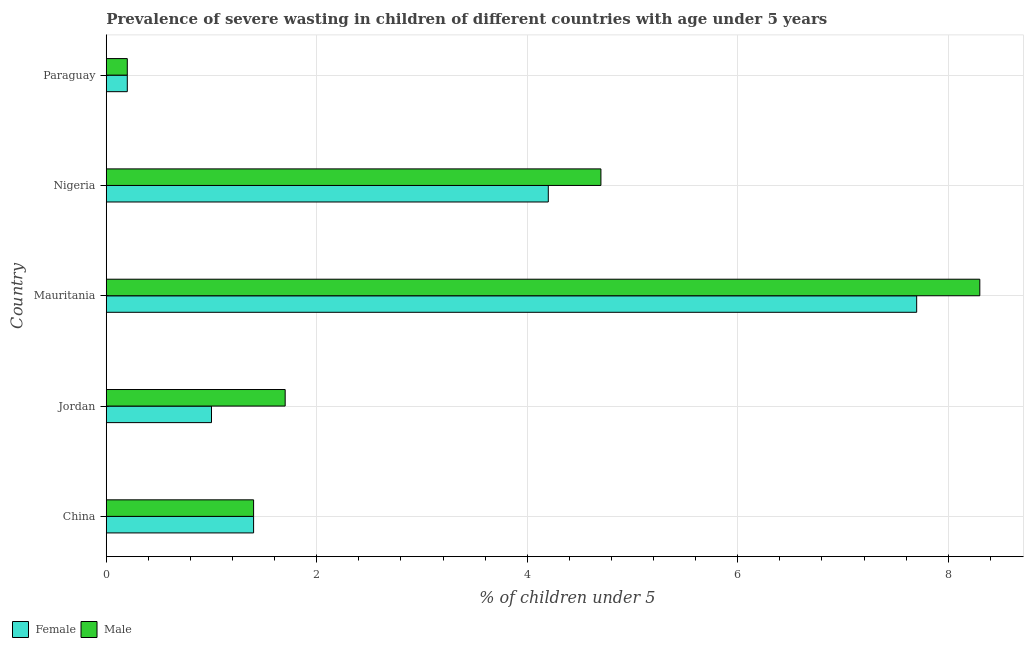How many different coloured bars are there?
Make the answer very short. 2. How many groups of bars are there?
Offer a terse response. 5. Are the number of bars per tick equal to the number of legend labels?
Offer a terse response. Yes. Are the number of bars on each tick of the Y-axis equal?
Offer a very short reply. Yes. How many bars are there on the 1st tick from the top?
Your answer should be compact. 2. What is the label of the 4th group of bars from the top?
Make the answer very short. Jordan. In how many cases, is the number of bars for a given country not equal to the number of legend labels?
Offer a terse response. 0. What is the percentage of undernourished male children in Paraguay?
Ensure brevity in your answer.  0.2. Across all countries, what is the maximum percentage of undernourished male children?
Keep it short and to the point. 8.3. Across all countries, what is the minimum percentage of undernourished female children?
Provide a succinct answer. 0.2. In which country was the percentage of undernourished male children maximum?
Make the answer very short. Mauritania. In which country was the percentage of undernourished male children minimum?
Offer a terse response. Paraguay. What is the total percentage of undernourished male children in the graph?
Make the answer very short. 16.3. What is the difference between the percentage of undernourished female children in China and the percentage of undernourished male children in Paraguay?
Your answer should be compact. 1.2. What is the average percentage of undernourished male children per country?
Give a very brief answer. 3.26. What is the difference between the percentage of undernourished female children and percentage of undernourished male children in Mauritania?
Make the answer very short. -0.6. What is the ratio of the percentage of undernourished male children in Jordan to that in Nigeria?
Your answer should be very brief. 0.36. What does the 1st bar from the top in China represents?
Make the answer very short. Male. What does the 2nd bar from the bottom in Nigeria represents?
Provide a short and direct response. Male. How many bars are there?
Ensure brevity in your answer.  10. Are all the bars in the graph horizontal?
Ensure brevity in your answer.  Yes. What is the difference between two consecutive major ticks on the X-axis?
Offer a terse response. 2. Where does the legend appear in the graph?
Your answer should be very brief. Bottom left. How are the legend labels stacked?
Your response must be concise. Horizontal. What is the title of the graph?
Keep it short and to the point. Prevalence of severe wasting in children of different countries with age under 5 years. Does "Male labourers" appear as one of the legend labels in the graph?
Offer a very short reply. No. What is the label or title of the X-axis?
Offer a terse response.  % of children under 5. What is the  % of children under 5 of Female in China?
Provide a short and direct response. 1.4. What is the  % of children under 5 in Male in China?
Offer a terse response. 1.4. What is the  % of children under 5 of Male in Jordan?
Provide a short and direct response. 1.7. What is the  % of children under 5 in Female in Mauritania?
Offer a terse response. 7.7. What is the  % of children under 5 in Male in Mauritania?
Make the answer very short. 8.3. What is the  % of children under 5 of Female in Nigeria?
Offer a very short reply. 4.2. What is the  % of children under 5 of Male in Nigeria?
Your answer should be compact. 4.7. What is the  % of children under 5 of Female in Paraguay?
Make the answer very short. 0.2. What is the  % of children under 5 of Male in Paraguay?
Offer a very short reply. 0.2. Across all countries, what is the maximum  % of children under 5 of Female?
Offer a very short reply. 7.7. Across all countries, what is the maximum  % of children under 5 of Male?
Your response must be concise. 8.3. Across all countries, what is the minimum  % of children under 5 of Female?
Make the answer very short. 0.2. Across all countries, what is the minimum  % of children under 5 in Male?
Keep it short and to the point. 0.2. What is the difference between the  % of children under 5 in Female in China and that in Jordan?
Ensure brevity in your answer.  0.4. What is the difference between the  % of children under 5 in Female in China and that in Mauritania?
Your answer should be compact. -6.3. What is the difference between the  % of children under 5 in Male in China and that in Mauritania?
Ensure brevity in your answer.  -6.9. What is the difference between the  % of children under 5 in Female in China and that in Paraguay?
Give a very brief answer. 1.2. What is the difference between the  % of children under 5 of Male in Jordan and that in Mauritania?
Your answer should be compact. -6.6. What is the difference between the  % of children under 5 of Male in Mauritania and that in Nigeria?
Provide a short and direct response. 3.6. What is the difference between the  % of children under 5 in Male in Mauritania and that in Paraguay?
Provide a succinct answer. 8.1. What is the difference between the  % of children under 5 of Female in China and the  % of children under 5 of Male in Jordan?
Your answer should be compact. -0.3. What is the difference between the  % of children under 5 of Female in China and the  % of children under 5 of Male in Mauritania?
Provide a succinct answer. -6.9. What is the difference between the  % of children under 5 in Female in China and the  % of children under 5 in Male in Paraguay?
Provide a short and direct response. 1.2. What is the difference between the  % of children under 5 of Female in Nigeria and the  % of children under 5 of Male in Paraguay?
Provide a short and direct response. 4. What is the average  % of children under 5 in Male per country?
Keep it short and to the point. 3.26. What is the difference between the  % of children under 5 in Female and  % of children under 5 in Male in China?
Your response must be concise. 0. What is the difference between the  % of children under 5 of Female and  % of children under 5 of Male in Jordan?
Your answer should be very brief. -0.7. What is the difference between the  % of children under 5 in Female and  % of children under 5 in Male in Nigeria?
Give a very brief answer. -0.5. What is the ratio of the  % of children under 5 of Male in China to that in Jordan?
Your answer should be very brief. 0.82. What is the ratio of the  % of children under 5 in Female in China to that in Mauritania?
Give a very brief answer. 0.18. What is the ratio of the  % of children under 5 in Male in China to that in Mauritania?
Your answer should be compact. 0.17. What is the ratio of the  % of children under 5 of Female in China to that in Nigeria?
Make the answer very short. 0.33. What is the ratio of the  % of children under 5 in Male in China to that in Nigeria?
Your response must be concise. 0.3. What is the ratio of the  % of children under 5 in Female in Jordan to that in Mauritania?
Offer a very short reply. 0.13. What is the ratio of the  % of children under 5 of Male in Jordan to that in Mauritania?
Provide a succinct answer. 0.2. What is the ratio of the  % of children under 5 in Female in Jordan to that in Nigeria?
Your answer should be very brief. 0.24. What is the ratio of the  % of children under 5 of Male in Jordan to that in Nigeria?
Give a very brief answer. 0.36. What is the ratio of the  % of children under 5 of Male in Jordan to that in Paraguay?
Provide a short and direct response. 8.5. What is the ratio of the  % of children under 5 in Female in Mauritania to that in Nigeria?
Your answer should be very brief. 1.83. What is the ratio of the  % of children under 5 of Male in Mauritania to that in Nigeria?
Ensure brevity in your answer.  1.77. What is the ratio of the  % of children under 5 of Female in Mauritania to that in Paraguay?
Make the answer very short. 38.5. What is the ratio of the  % of children under 5 in Male in Mauritania to that in Paraguay?
Keep it short and to the point. 41.5. What is the ratio of the  % of children under 5 in Male in Nigeria to that in Paraguay?
Provide a succinct answer. 23.5. What is the difference between the highest and the second highest  % of children under 5 of Female?
Offer a very short reply. 3.5. What is the difference between the highest and the second highest  % of children under 5 in Male?
Your answer should be very brief. 3.6. What is the difference between the highest and the lowest  % of children under 5 in Female?
Give a very brief answer. 7.5. What is the difference between the highest and the lowest  % of children under 5 of Male?
Provide a succinct answer. 8.1. 